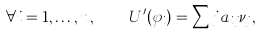<formula> <loc_0><loc_0><loc_500><loc_500>\forall i = 1 , \dots , n , \quad U ^ { \prime } ( \varphi _ { i } ) = \sum j a _ { i j } \nu _ { j } ,</formula> 